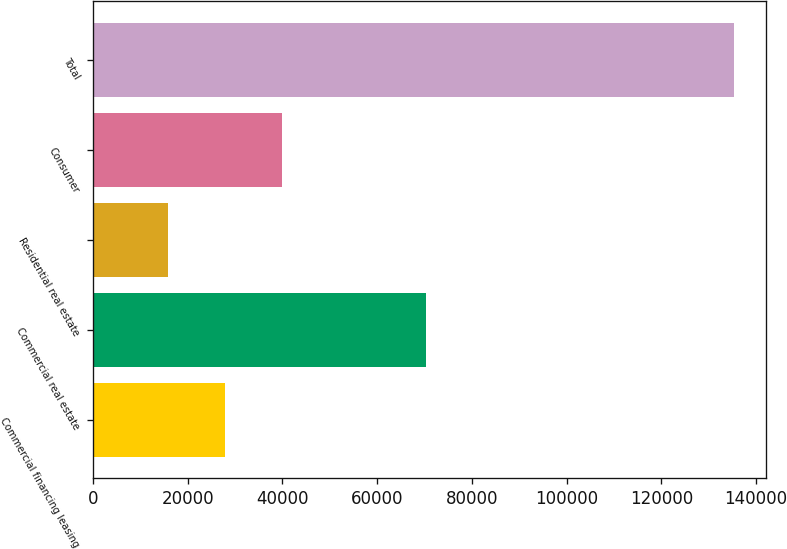<chart> <loc_0><loc_0><loc_500><loc_500><bar_chart><fcel>Commercial financing leasing<fcel>Commercial real estate<fcel>Residential real estate<fcel>Consumer<fcel>Total<nl><fcel>27901.2<fcel>70261<fcel>15958<fcel>39844.4<fcel>135390<nl></chart> 